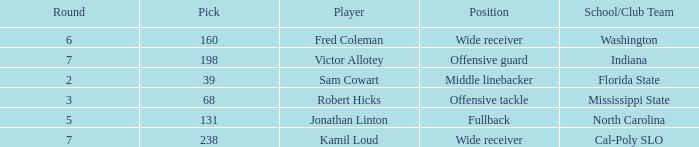Which School/Club Team has a Pick of 198? Indiana. 